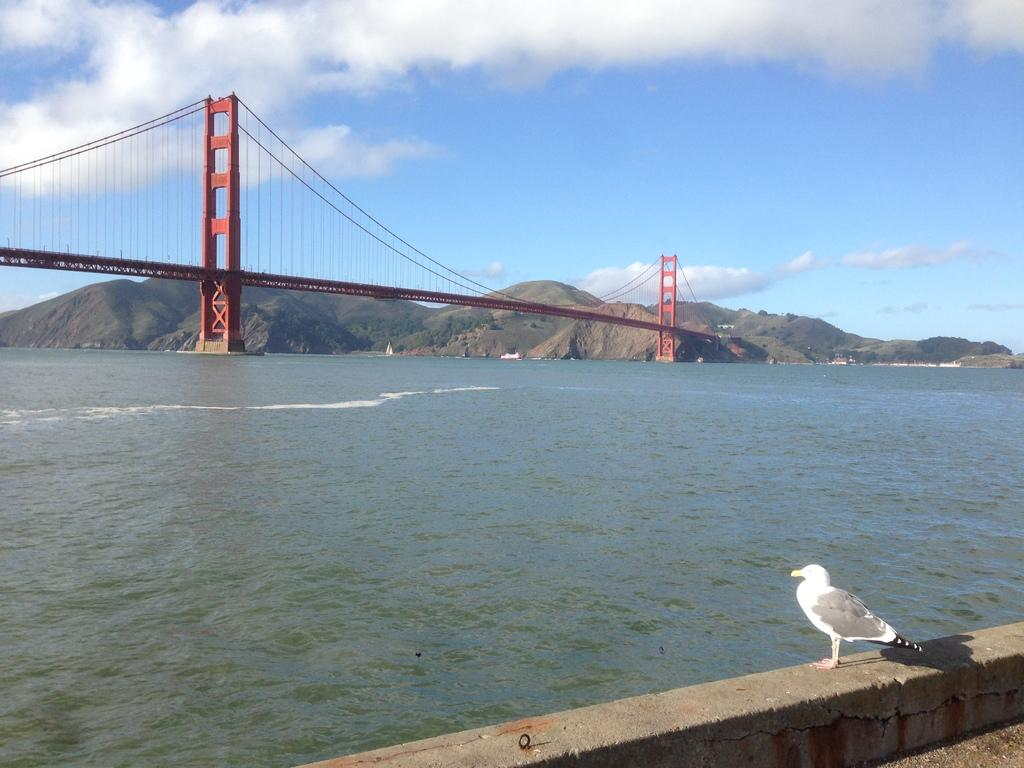What is on the wall in the image? There is a bird on the wall in the image. What structure can be seen on the water in the image? There is a bridge on the water in the image. What natural features are visible in the background of the image? Mountains and trees are visible in the background of the image. How would you describe the sky in the image? The sky is cloudy in the background of the image. What type of kettle is being used to talk to the cloth in the image? There is no kettle or cloth present in the image. What type of conversation is the bird having with the bridge in the image? The image does not depict any talking or conversation between the bird and the bridge. 